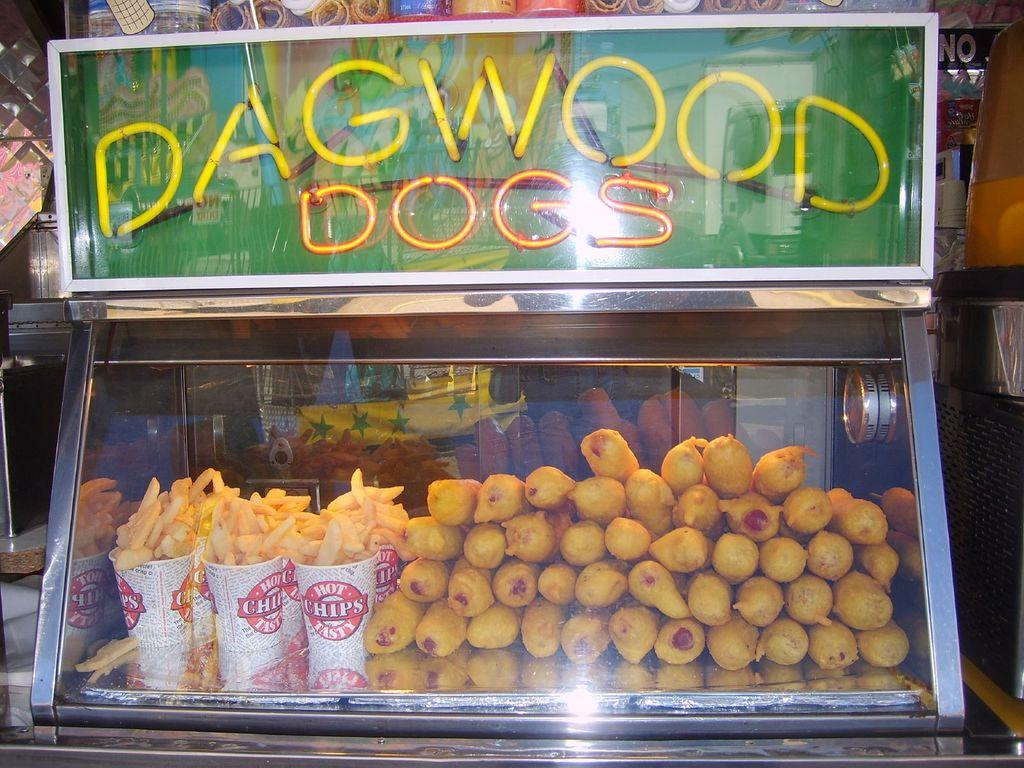What is the main object in the image? There is a board in the image. What can be seen inside the glass box in the image? There are food items in a glass box in the image. What is visible through the glass in the image? A cloth is visible through the glass in the image. What type of amusement can be seen in the image? There is no amusement present in the image; it features a board, food items in a glass box, and a cloth visible through the glass. What is the selection of food items available in the image? The image only shows food items in a glass box, but it does not provide information about the specific types of food available. 